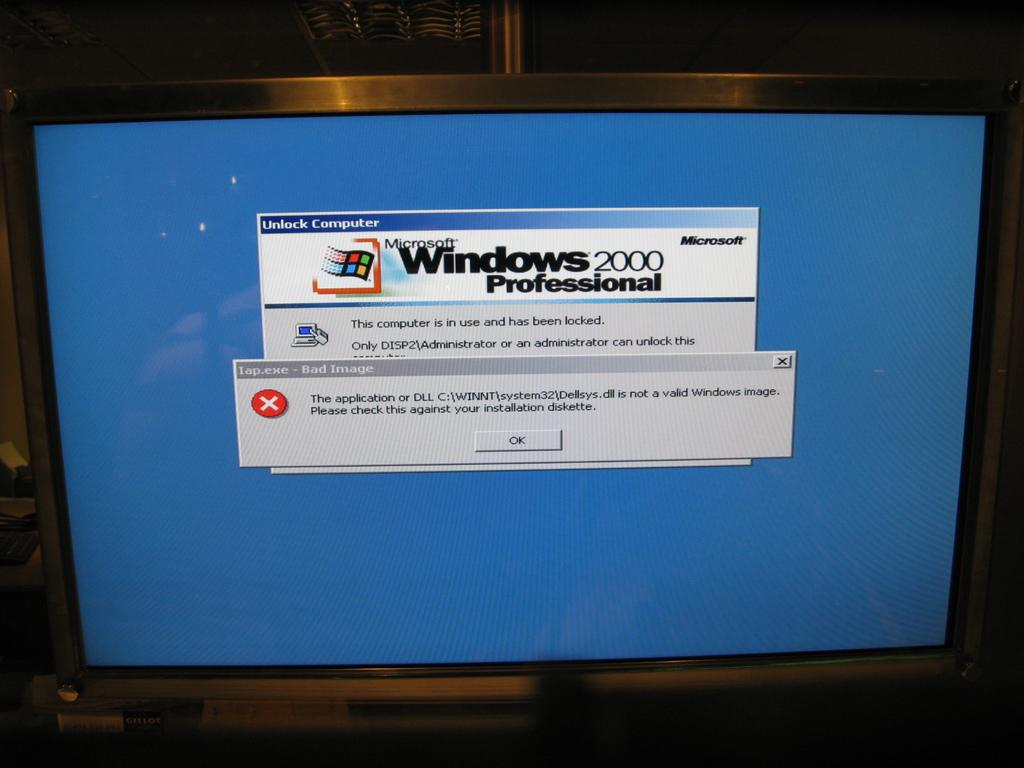<image>
Provide a brief description of the given image. Blue desktop computer screen showing the computer is in use and is locked. 